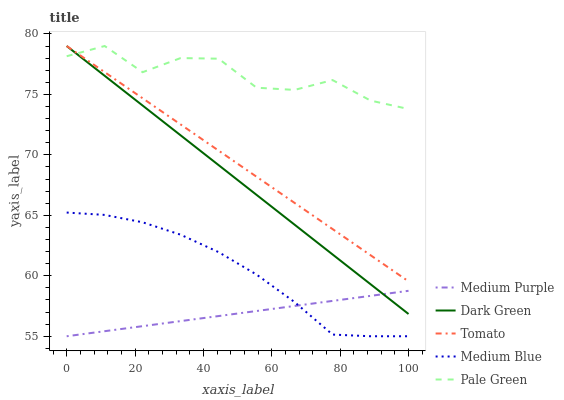Does Medium Purple have the minimum area under the curve?
Answer yes or no. Yes. Does Pale Green have the maximum area under the curve?
Answer yes or no. Yes. Does Tomato have the minimum area under the curve?
Answer yes or no. No. Does Tomato have the maximum area under the curve?
Answer yes or no. No. Is Medium Purple the smoothest?
Answer yes or no. Yes. Is Pale Green the roughest?
Answer yes or no. Yes. Is Tomato the smoothest?
Answer yes or no. No. Is Tomato the roughest?
Answer yes or no. No. Does Medium Purple have the lowest value?
Answer yes or no. Yes. Does Tomato have the lowest value?
Answer yes or no. No. Does Dark Green have the highest value?
Answer yes or no. Yes. Does Medium Blue have the highest value?
Answer yes or no. No. Is Medium Purple less than Pale Green?
Answer yes or no. Yes. Is Tomato greater than Medium Blue?
Answer yes or no. Yes. Does Dark Green intersect Medium Purple?
Answer yes or no. Yes. Is Dark Green less than Medium Purple?
Answer yes or no. No. Is Dark Green greater than Medium Purple?
Answer yes or no. No. Does Medium Purple intersect Pale Green?
Answer yes or no. No. 